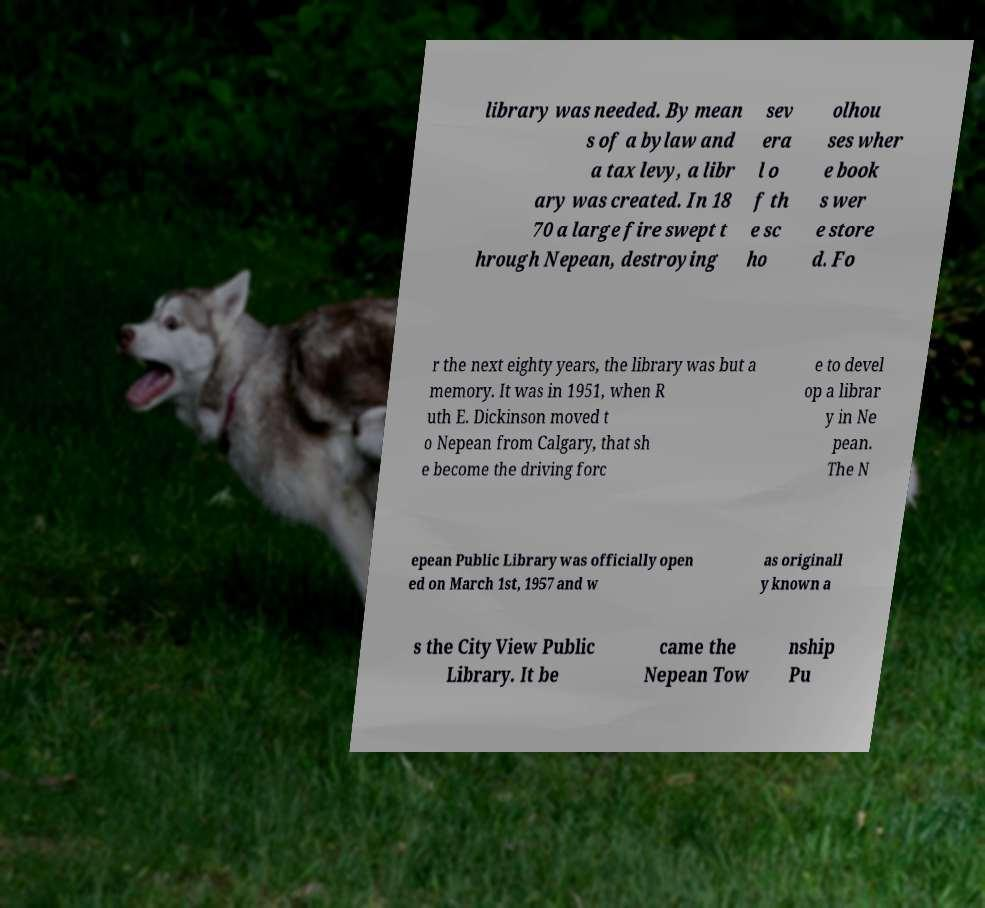Please read and relay the text visible in this image. What does it say? library was needed. By mean s of a bylaw and a tax levy, a libr ary was created. In 18 70 a large fire swept t hrough Nepean, destroying sev era l o f th e sc ho olhou ses wher e book s wer e store d. Fo r the next eighty years, the library was but a memory. It was in 1951, when R uth E. Dickinson moved t o Nepean from Calgary, that sh e become the driving forc e to devel op a librar y in Ne pean. The N epean Public Library was officially open ed on March 1st, 1957 and w as originall y known a s the City View Public Library. It be came the Nepean Tow nship Pu 